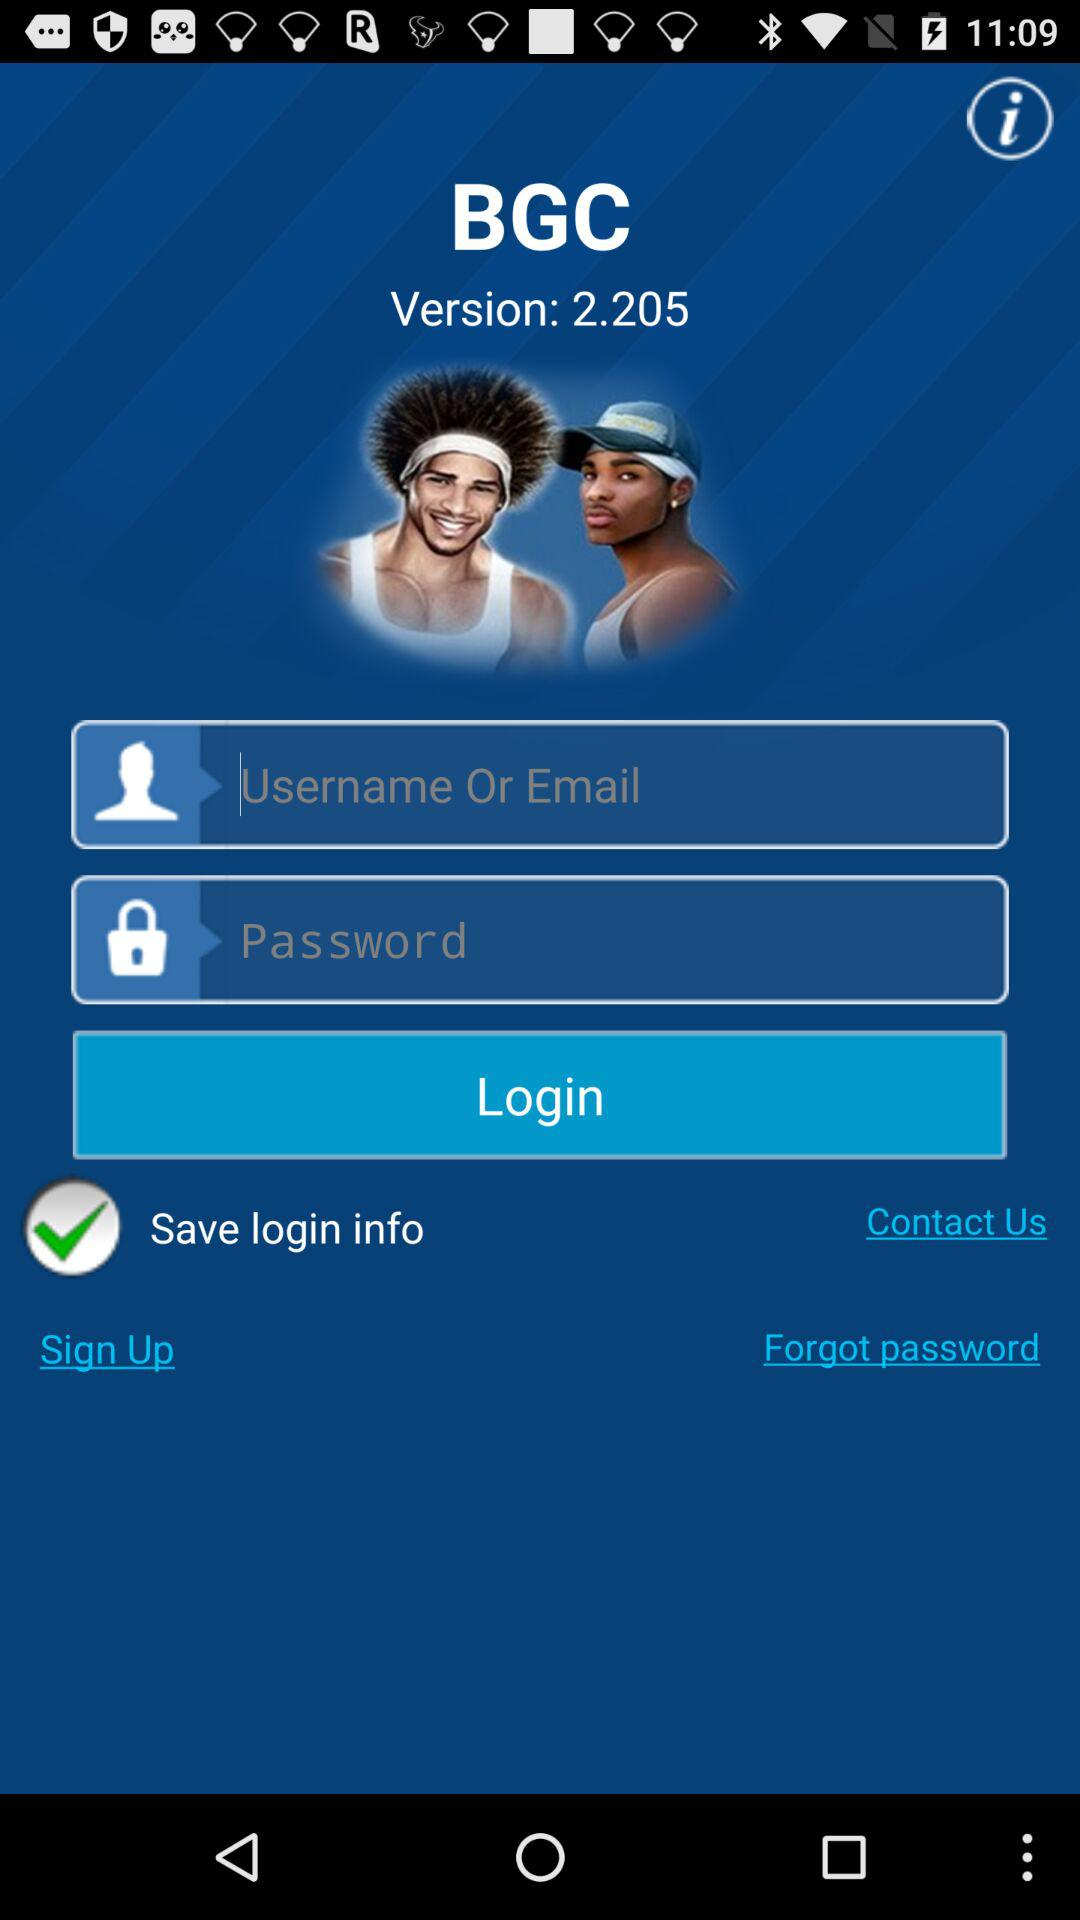What is the version of the application? The version is 2.205. 